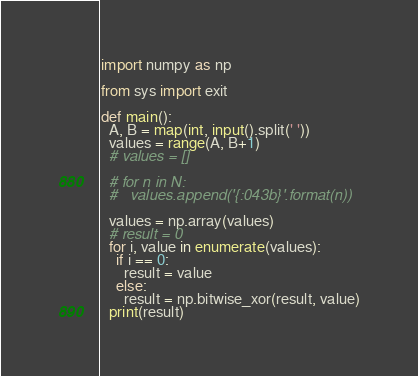Convert code to text. <code><loc_0><loc_0><loc_500><loc_500><_Python_>import numpy as np

from sys import exit

def main():
  A, B = map(int, input().split(' '))
  values = range(A, B+1)
  # values = []

  # for n in N:
  #   values.append('{:043b}'.format(n))

  values = np.array(values)
  # result = 0
  for i, value in enumerate(values):
    if i == 0:
      result = value
    else:
      result = np.bitwise_xor(result, value)
  print(result)</code> 